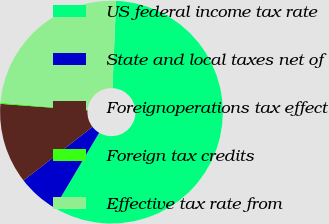Convert chart. <chart><loc_0><loc_0><loc_500><loc_500><pie_chart><fcel>US federal income tax rate<fcel>State and local taxes net of<fcel>Foreignoperations tax effect<fcel>Foreign tax credits<fcel>Effective tax rate from<nl><fcel>57.88%<fcel>5.94%<fcel>11.71%<fcel>0.17%<fcel>24.31%<nl></chart> 